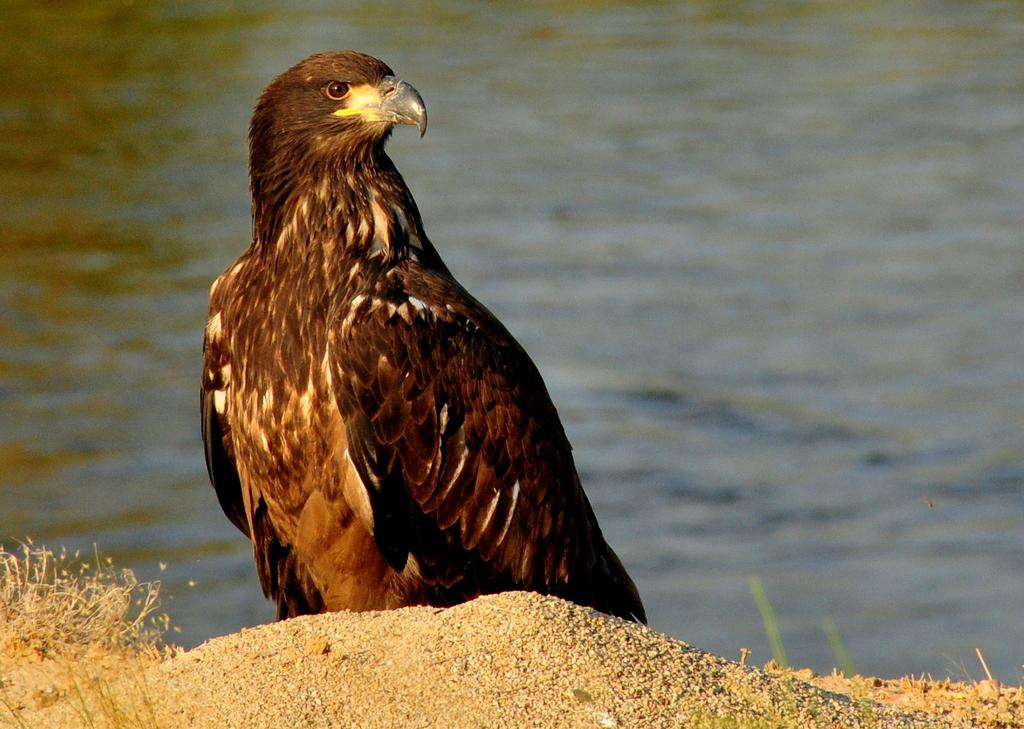What animal is in the foreground of the picture? There is an eagle in the foreground of the picture. What type of terrain is visible in the foreground of the picture? Sand and grass are visible in the foreground of the picture. What can be seen in the background of the picture? There is a water body in the background of the picture. Where is the queen sitting with her horse and banana in the image? There is no queen, horse, or banana present in the image; it features an eagle in the foreground. 